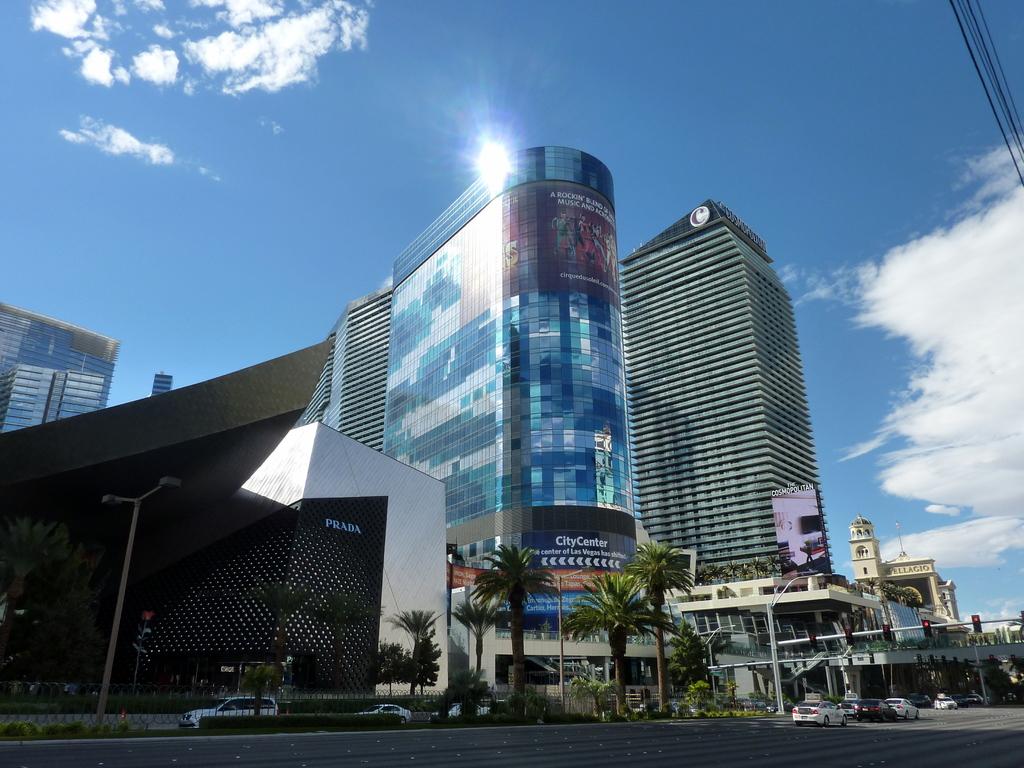What is the name of the business in the black building?
Your answer should be compact. Prada. What is the on the middle building?
Offer a terse response. City center. 